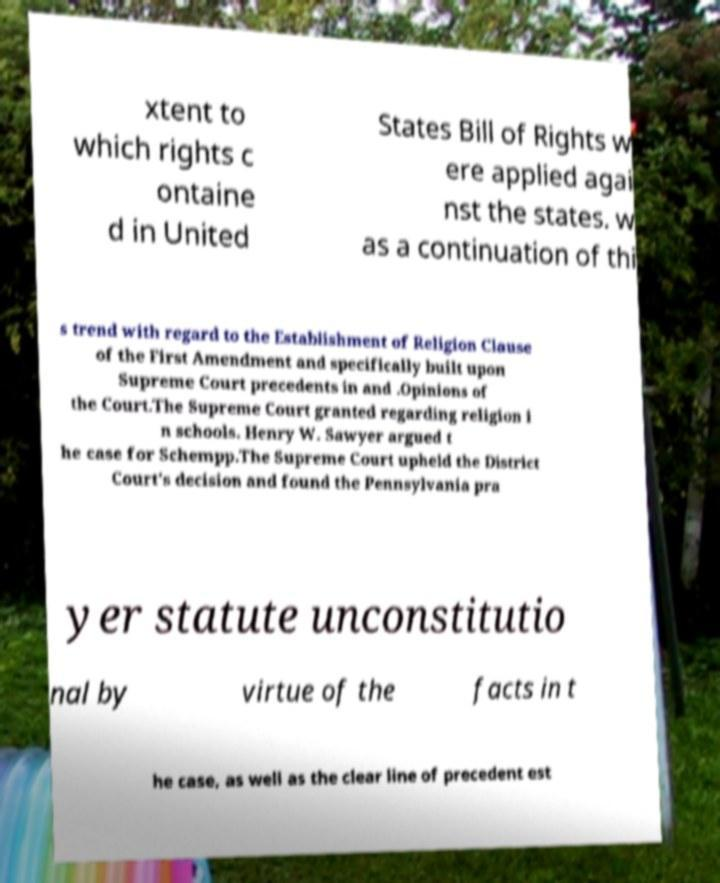I need the written content from this picture converted into text. Can you do that? xtent to which rights c ontaine d in United States Bill of Rights w ere applied agai nst the states. w as a continuation of thi s trend with regard to the Establishment of Religion Clause of the First Amendment and specifically built upon Supreme Court precedents in and .Opinions of the Court.The Supreme Court granted regarding religion i n schools. Henry W. Sawyer argued t he case for Schempp.The Supreme Court upheld the District Court's decision and found the Pennsylvania pra yer statute unconstitutio nal by virtue of the facts in t he case, as well as the clear line of precedent est 